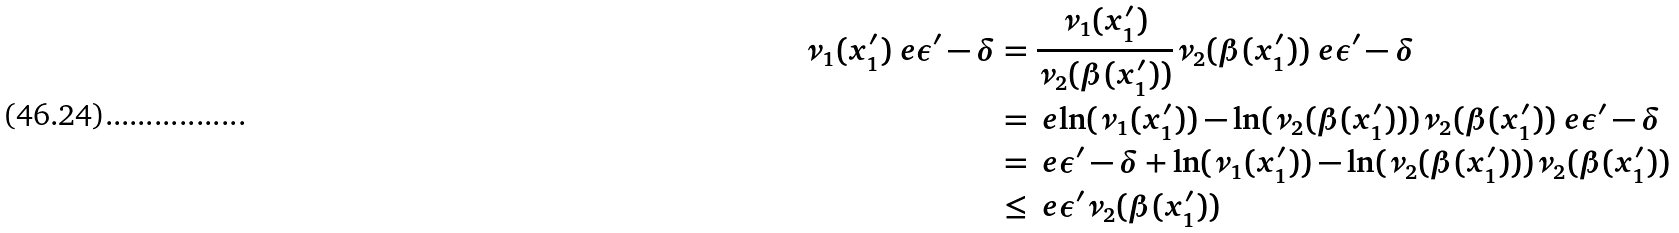<formula> <loc_0><loc_0><loc_500><loc_500>\nu _ { 1 } ( x ^ { \prime } _ { 1 } ) \ e { \epsilon ^ { \prime } - \delta } & = \frac { \nu _ { 1 } ( x ^ { \prime } _ { 1 } ) } { \nu _ { 2 } ( \beta ( x ^ { \prime } _ { 1 } ) ) } \nu _ { 2 } ( \beta ( x ^ { \prime } _ { 1 } ) ) \ e { \epsilon ^ { \prime } - \delta } \\ & = \ e { \ln ( \nu _ { 1 } ( x ^ { \prime } _ { 1 } ) ) - \ln ( \nu _ { 2 } ( \beta ( x ^ { \prime } _ { 1 } ) ) ) } \nu _ { 2 } ( \beta ( x ^ { \prime } _ { 1 } ) ) \ e { \epsilon ^ { \prime } - \delta } \\ & = \ e { \epsilon ^ { \prime } - \delta + \ln ( \nu _ { 1 } ( x ^ { \prime } _ { 1 } ) ) - \ln ( \nu _ { 2 } ( \beta ( x ^ { \prime } _ { 1 } ) ) ) } \nu _ { 2 } ( \beta ( x ^ { \prime } _ { 1 } ) ) \\ & \leq \ e { \epsilon ^ { \prime } } \nu _ { 2 } ( \beta ( x ^ { \prime } _ { 1 } ) )</formula> 